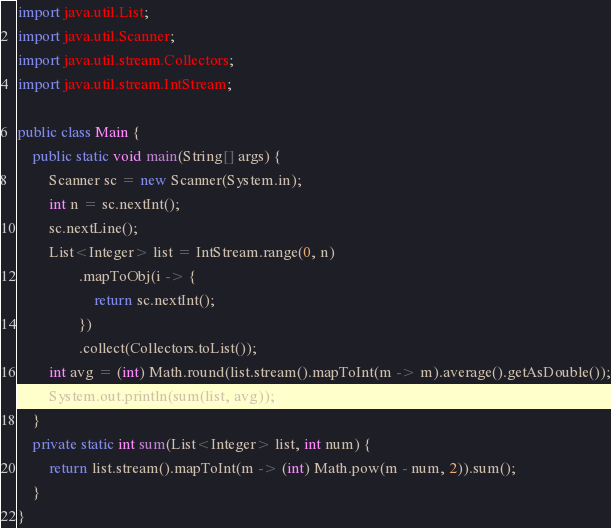<code> <loc_0><loc_0><loc_500><loc_500><_Java_>import java.util.List;
import java.util.Scanner;
import java.util.stream.Collectors;
import java.util.stream.IntStream;

public class Main {
    public static void main(String[] args) {
        Scanner sc = new Scanner(System.in);
        int n = sc.nextInt();
        sc.nextLine();
        List<Integer> list = IntStream.range(0, n)
                .mapToObj(i -> {
                    return sc.nextInt();
                })
                .collect(Collectors.toList());
        int avg = (int) Math.round(list.stream().mapToInt(m -> m).average().getAsDouble());
        System.out.println(sum(list, avg));
    }
    private static int sum(List<Integer> list, int num) {
        return list.stream().mapToInt(m -> (int) Math.pow(m - num, 2)).sum();
    }
}
</code> 